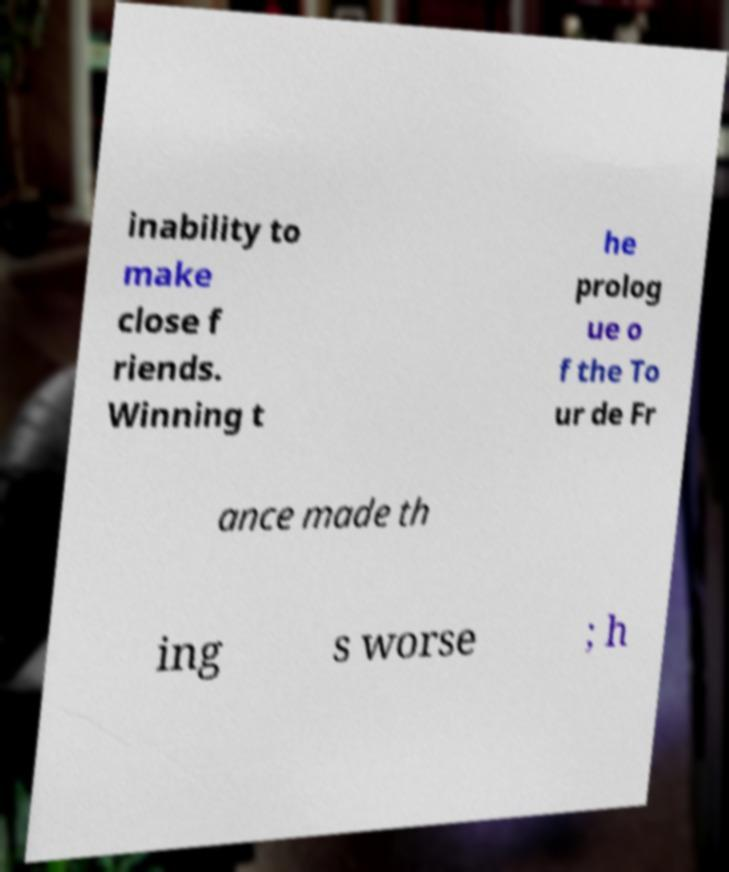What messages or text are displayed in this image? I need them in a readable, typed format. inability to make close f riends. Winning t he prolog ue o f the To ur de Fr ance made th ing s worse ; h 